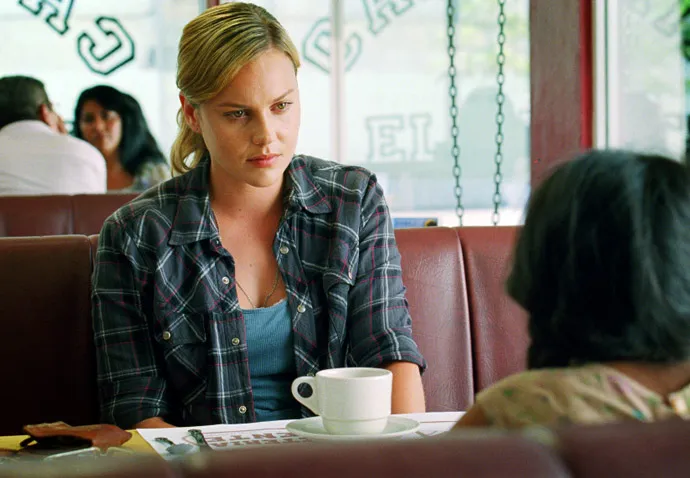Create an entirely different scenario for this image, something unusual or unexpected. In a hidden corner of the bustling city, this unassuming diner is actually a front for an elite undercover organization. The woman in the plaid shirt, Agent Harper, is in the middle of a covert mission. The person across from her is a key informant with critical information about a global threat. As they converse in hushed tones, eyes darting around to ensure their secrecy, Harper receives a secret code written on a napkin. The coffee cup in front of her is a cleverly disguised communication device. While everything seems calm, she's prepared for any sudden move, ready to act to safeguard the mission and protect the world's balance. What happens next in this spy scenario? Agent Harper discreetly glances at the napkin and deciphers the code hastily scribbled on it. Suddenly, the diner’s front door swings open, and a group of suspicious-looking men enters, their eyes scanning the room. Harper maintains her composure, continuing her conversation as if nothing is amiss. The informant across from her starts to tremble slightly, realizing the danger.

Harper subtly presses a hidden button on her coffee cup, sending an encrypted distress signal to her team. The men approach the booth, and as they draw nearer, Harper signals to the informant to stay calm. Just as the men reach their table, a burst of smoke fills the room, an emergency protocol initiated by Harper's hidden device.

In the confusion, Harper and the informant slip out through a side exit, blending into the bustling alley outside. A black SUV pulls up, and they quickly get in, speeding off to safety. Harper turns to the informant, 'We’re not safe yet. There’s a safe house nearby where we can lay low and plan our next move.' They drive off into the city, ready to unravel the deeper conspiracy at hand. Wow, that’s thrilling! Can you describe the safe house in detail? The safe house, nestled in a quiet suburban neighborhood, appears to be an ordinary two-story home from the outside. Its exterior is unremarkable, blending seamlessly with the other houses on the street. However, as Agent Harper and the informant step inside, the true nature of the safe house is revealed.

The living room is equipped with high-tech surveillance systems, screens displaying live feeds from various locations. Maps and blueprints are pinned to the walls, and a large, sturdy table in the center is cluttered with dossiers, gadgets, and weapons. The basement serves as an operations center, complete with encrypted communication lines, a mini armory, and a workspace for forensics and computer hacking.

In contrast, the top floor is designed for comfort and security, with cozy bedrooms and a well-stocked kitchen. Thick, bulletproof curtains cover the windows, and hidden panels provide quick exits and panic rooms in case of emergency. Even the seemingly mundane household items double as defensive tools or hidden compartments.

As Harper and the informant settle in, the house's AI system activates, ensuring the perimeter is secure. The bright hallways contrast sharply with the gravity of their mission, but within these walls, they find a brief sanctuary to plan and prepare for the challenges ahead. 